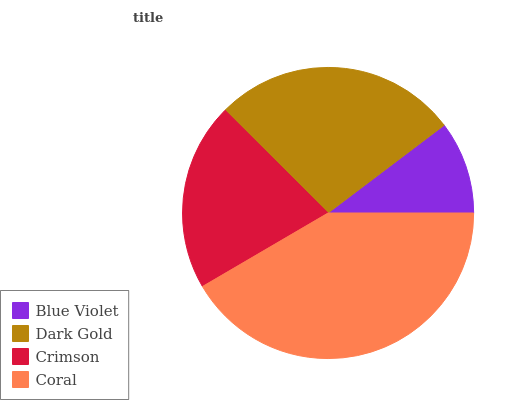Is Blue Violet the minimum?
Answer yes or no. Yes. Is Coral the maximum?
Answer yes or no. Yes. Is Dark Gold the minimum?
Answer yes or no. No. Is Dark Gold the maximum?
Answer yes or no. No. Is Dark Gold greater than Blue Violet?
Answer yes or no. Yes. Is Blue Violet less than Dark Gold?
Answer yes or no. Yes. Is Blue Violet greater than Dark Gold?
Answer yes or no. No. Is Dark Gold less than Blue Violet?
Answer yes or no. No. Is Dark Gold the high median?
Answer yes or no. Yes. Is Crimson the low median?
Answer yes or no. Yes. Is Blue Violet the high median?
Answer yes or no. No. Is Blue Violet the low median?
Answer yes or no. No. 